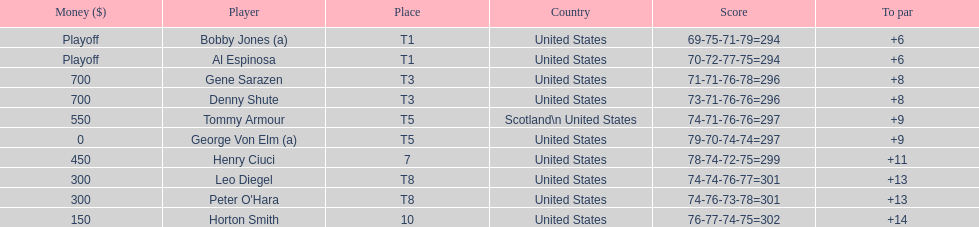Which two players tied for first place? Bobby Jones (a), Al Espinosa. 